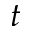Convert formula to latex. <formula><loc_0><loc_0><loc_500><loc_500>t</formula> 